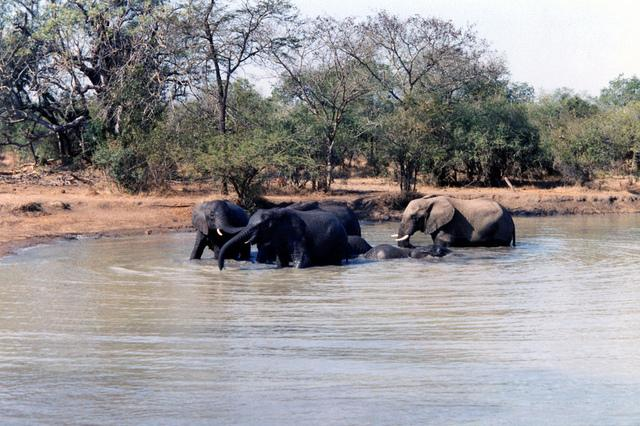Who has the last name that refers to what a group of these animals is called? herd 